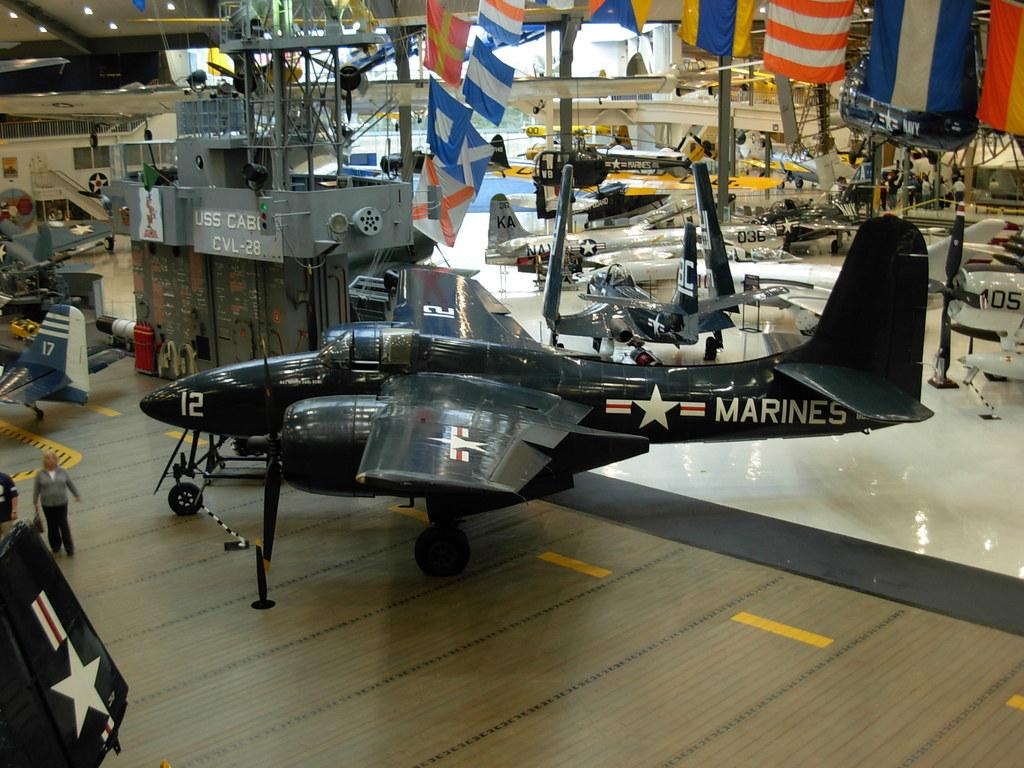<image>
Provide a brief description of the given image. an airplane from the marines in a museum 